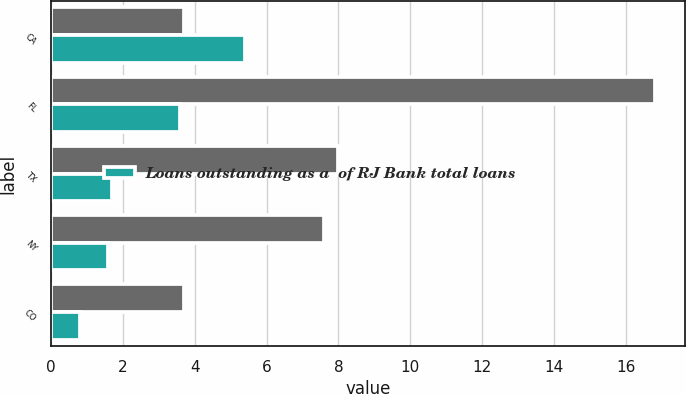<chart> <loc_0><loc_0><loc_500><loc_500><stacked_bar_chart><ecel><fcel>CA<fcel>FL<fcel>TX<fcel>NY<fcel>CO<nl><fcel>nan<fcel>3.7<fcel>16.8<fcel>8<fcel>7.6<fcel>3.7<nl><fcel>Loans outstanding as a  of RJ Bank total loans<fcel>5.4<fcel>3.6<fcel>1.7<fcel>1.6<fcel>0.8<nl></chart> 